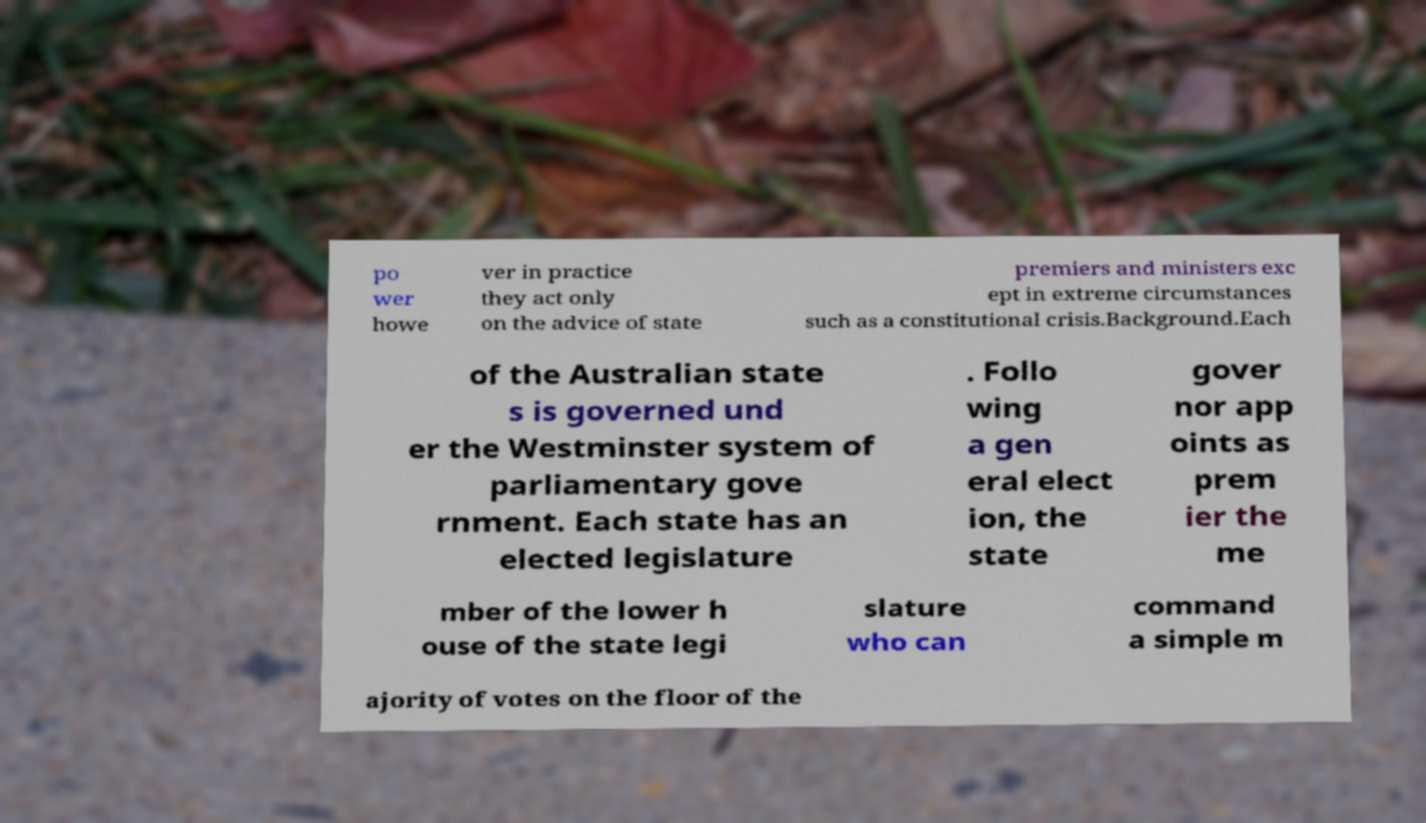Please identify and transcribe the text found in this image. po wer howe ver in practice they act only on the advice of state premiers and ministers exc ept in extreme circumstances such as a constitutional crisis.Background.Each of the Australian state s is governed und er the Westminster system of parliamentary gove rnment. Each state has an elected legislature . Follo wing a gen eral elect ion, the state gover nor app oints as prem ier the me mber of the lower h ouse of the state legi slature who can command a simple m ajority of votes on the floor of the 